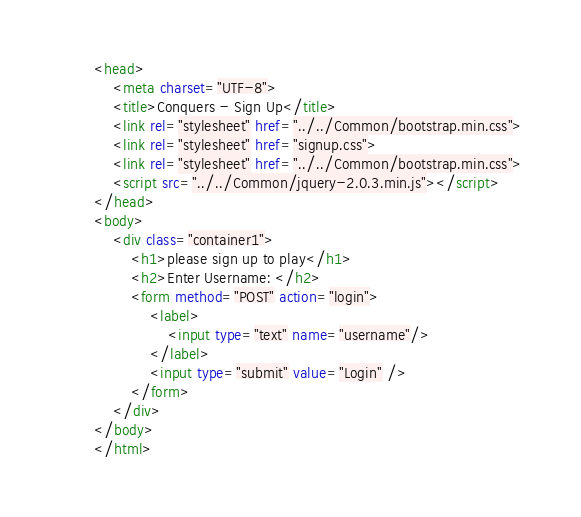<code> <loc_0><loc_0><loc_500><loc_500><_HTML_><head>
    <meta charset="UTF-8">
    <title>Conquers - Sign Up</title>
    <link rel="stylesheet" href="../../Common/bootstrap.min.css">
    <link rel="stylesheet" href="signup.css">
    <link rel="stylesheet" href="../../Common/bootstrap.min.css">
    <script src="../../Common/jquery-2.0.3.min.js"></script>
</head>
<body>
    <div class="container1">
        <h1>please sign up to play</h1>
        <h2>Enter Username: </h2>
        <form method="POST" action="login">
            <label>
                <input type="text" name="username"/>
            </label>
            <input type="submit" value="Login" />
        </form>
    </div>
</body>
</html></code> 